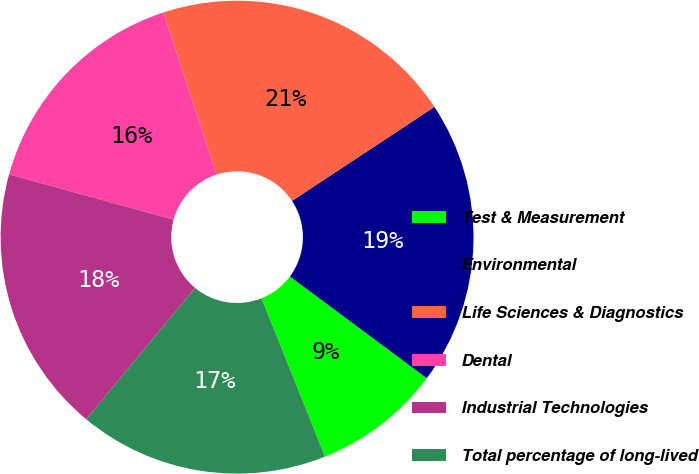Convert chart. <chart><loc_0><loc_0><loc_500><loc_500><pie_chart><fcel>Test & Measurement<fcel>Environmental<fcel>Life Sciences & Diagnostics<fcel>Dental<fcel>Industrial Technologies<fcel>Total percentage of long-lived<nl><fcel>8.76%<fcel>19.46%<fcel>20.76%<fcel>15.68%<fcel>18.27%<fcel>17.07%<nl></chart> 